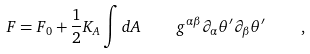Convert formula to latex. <formula><loc_0><loc_0><loc_500><loc_500>F = F _ { 0 } + \frac { 1 } { 2 } K _ { A } \int d A \, \quad g ^ { \alpha \beta } \partial _ { \alpha } \theta ^ { \prime } \partial _ { \beta } \theta ^ { \prime } \, \quad ,</formula> 